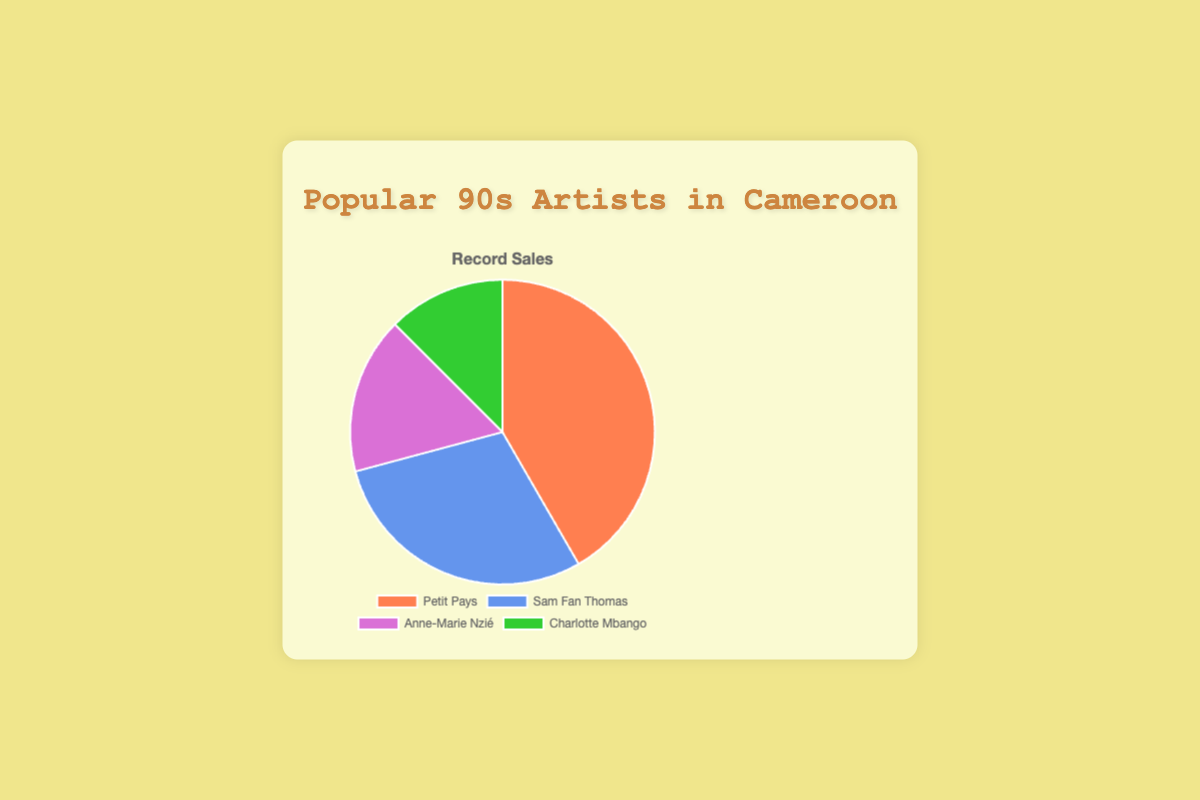What percentage of the total record sales does Petit Pays have? To find this, sum all the record sales (500,000 + 350,000 + 200,000 + 150,000 = 1,200,000). Then, divide Petit Pays' record sales by the total and multiply by 100 to get the percentage: (500,000 / 1,200,000) * 100 ≈ 41.67%.
Answer: 41.67% Which artist has the second-highest record sales? By looking at the record sales numbers, the artist with the second-highest sales is Sam Fan Thomas with 350,000 sales.
Answer: Sam Fan Thomas What is the difference in record sales between Anne-Marie Nzié and Charlotte Mbango? Subtract Charlotte Mbango's sales from Anne-Marie Nzié's sales: 200,000 - 150,000 = 50,000.
Answer: 50,000 What fraction of the total record sales does Charlotte Mbango have? Sum all the record sales (1,200,000). Then, divide Charlotte Mbango's record sales by the total: 150,000 / 1,200,000 = 1/8.
Answer: 1/8 Which artist has the smallest proportion of record sales, and what is their percentage share? Charlotte Mbango has the smallest record sales (150,000). To find the percentage, (150,000 / 1,200,000) * 100 ≈ 12.5%.
Answer: Charlotte Mbango, 12.5% Sum the record sales of the two artists with the highest sales and compare it to the combined sales of the remaining two artists. The sum of the top two artists (Petit Pays and Sam Fan Thomas) is 500,000 + 350,000 = 850,000. The sum of the remaining two (Anne-Marie Nzié and Charlotte Mbango) is 200,000 + 150,000 = 350,000. The top two combined have more sales (850,000 is greater than 350,000).
Answer: The top two artists have more sales What is the average record sales per artist? Sum all the record sales (1,200,000) and divide by the number of artists (4): 1,200,000 / 4 = 300,000.
Answer: 300,000 What is the total record sales for the bottom three artists? Sum the record sales of Sam Fan Thomas, Anne-Marie Nzié, and Charlotte Mbango: 350,000 + 200,000 + 150,000 = 700,000.
Answer: 700,000 Are there any artists with record sales above 40% of the total? If yes, who are they? Calculate 40% of the total record sales (1,200,000) which is 480,000. Petit Pays has sales of 500,000, which is above 40%.
Answer: Petit Pays How do the combined record sales of Anne-Marie Nzié and Charlotte Mbango compare to those of Sam Fan Thomas? Sum the record sales of Anne-Marie Nzié and Charlotte Mbango: 200,000 + 150,000 = 350,000. This is equal to the record sales of Sam Fan Thomas, which are also 350,000.
Answer: Equal 